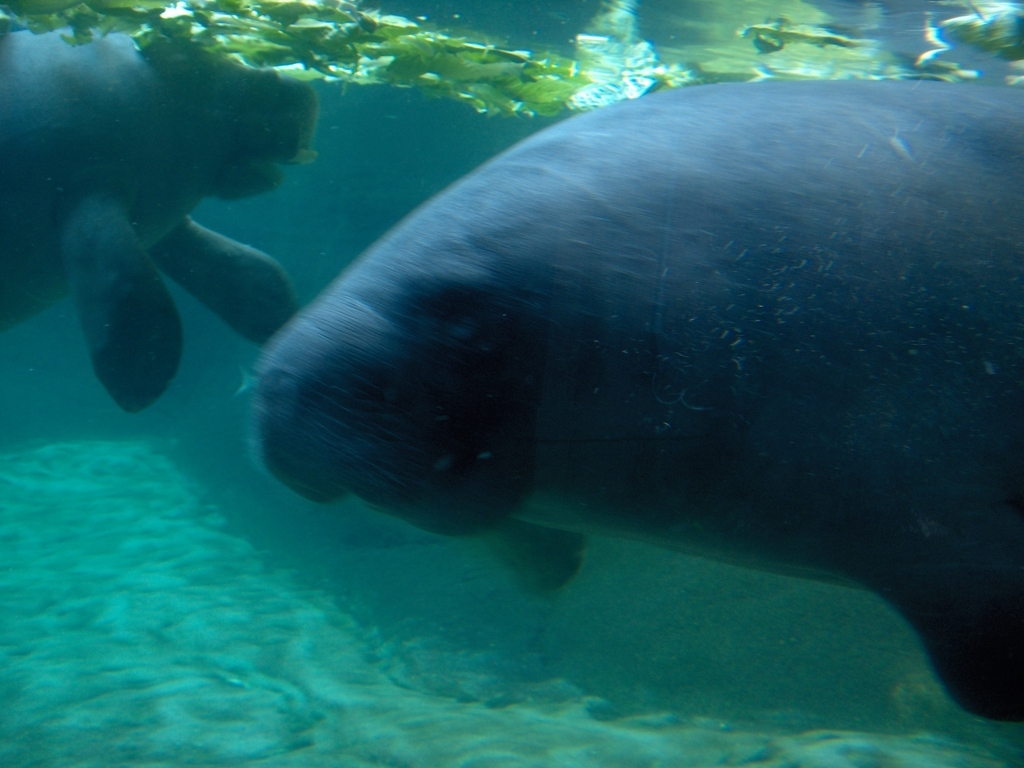What time of day does this photo appear to have been taken? Considering the natural light filtering through the water and the visibility of the surroundings, the photo likely was taken during daylight hours, although it's hard to determine the exact time without more context. 